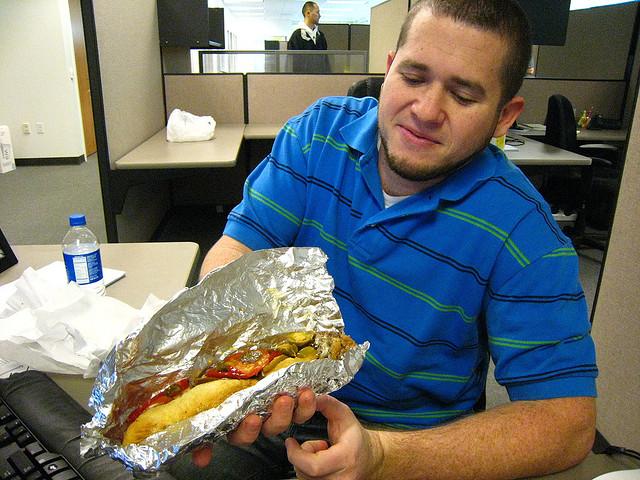Where is the plate?
Concise answer only. No plate. Is the person happy with his meal?
Keep it brief. Yes. What food will the man be eating?
Keep it brief. Hot dog. Is this man sitting?
Be succinct. Yes. Where is the water bottle?
Give a very brief answer. Table. 